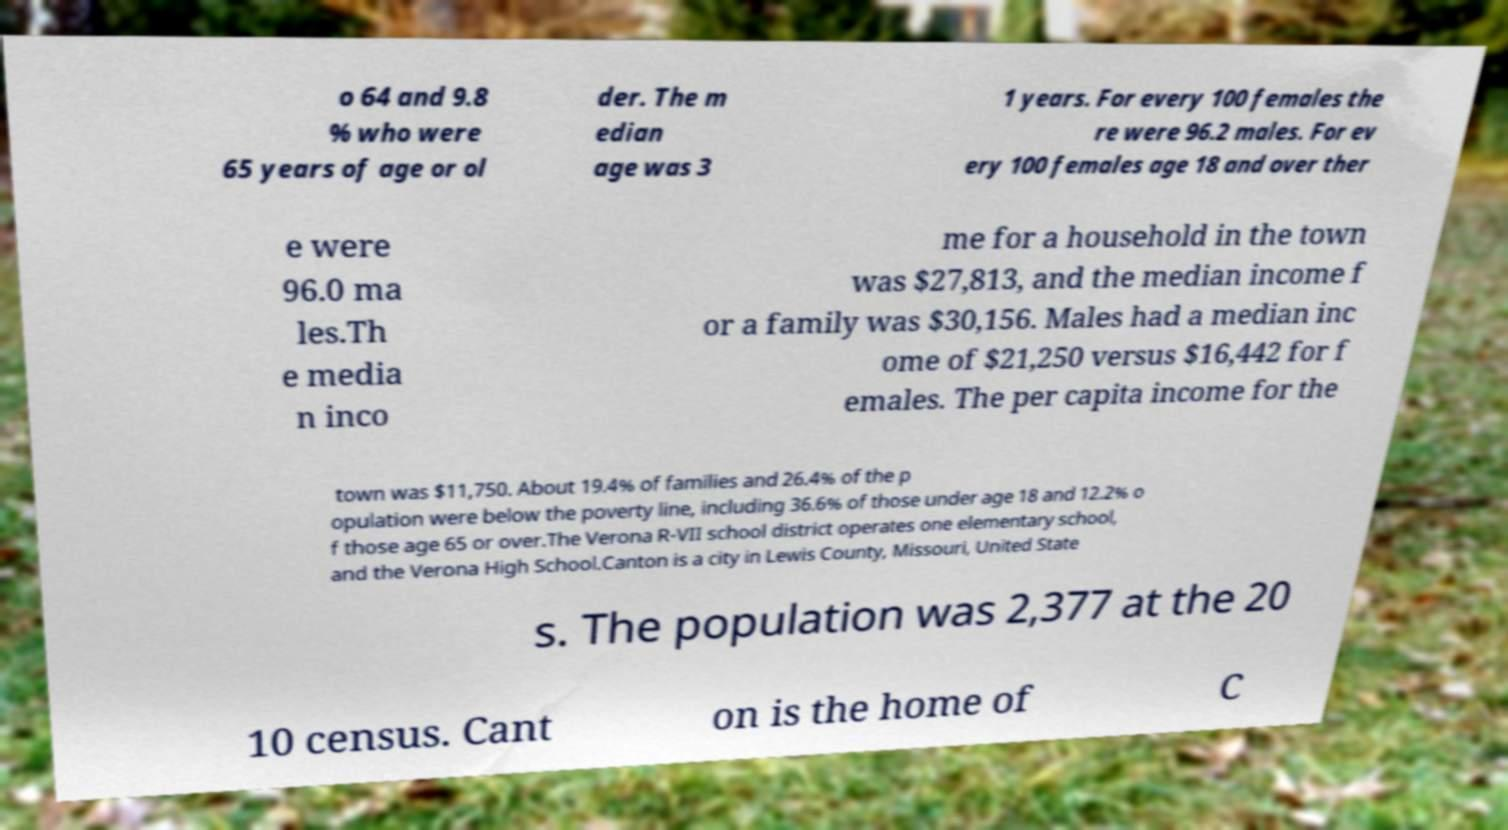What messages or text are displayed in this image? I need them in a readable, typed format. o 64 and 9.8 % who were 65 years of age or ol der. The m edian age was 3 1 years. For every 100 females the re were 96.2 males. For ev ery 100 females age 18 and over ther e were 96.0 ma les.Th e media n inco me for a household in the town was $27,813, and the median income f or a family was $30,156. Males had a median inc ome of $21,250 versus $16,442 for f emales. The per capita income for the town was $11,750. About 19.4% of families and 26.4% of the p opulation were below the poverty line, including 36.6% of those under age 18 and 12.2% o f those age 65 or over.The Verona R-VII school district operates one elementary school, and the Verona High School.Canton is a city in Lewis County, Missouri, United State s. The population was 2,377 at the 20 10 census. Cant on is the home of C 